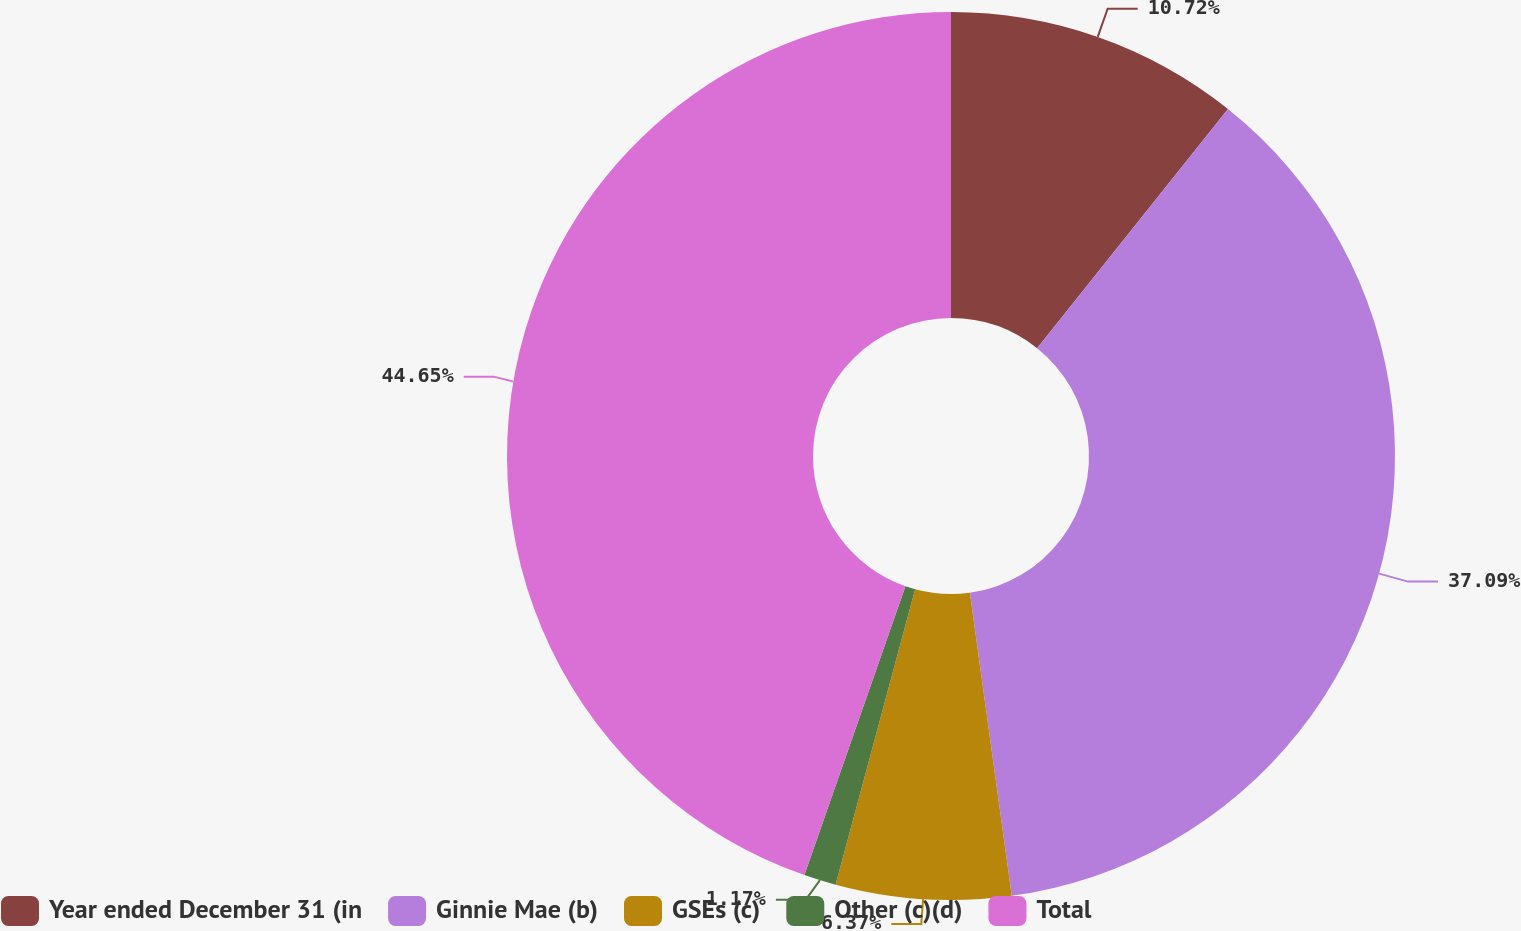Convert chart. <chart><loc_0><loc_0><loc_500><loc_500><pie_chart><fcel>Year ended December 31 (in<fcel>Ginnie Mae (b)<fcel>GSEs (c)<fcel>Other (c)(d)<fcel>Total<nl><fcel>10.72%<fcel>37.09%<fcel>6.37%<fcel>1.17%<fcel>44.64%<nl></chart> 